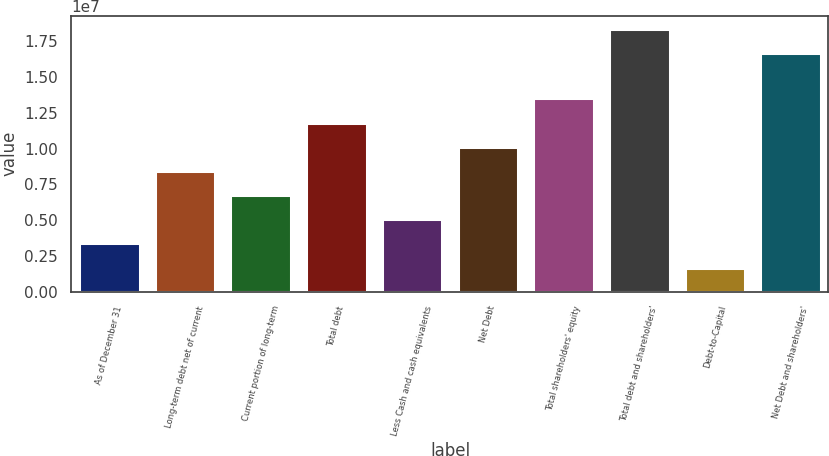Convert chart. <chart><loc_0><loc_0><loc_500><loc_500><bar_chart><fcel>As of December 31<fcel>Long-term debt net of current<fcel>Current portion of long-term<fcel>Total debt<fcel>Less Cash and cash equivalents<fcel>Net Debt<fcel>Total shareholders' equity<fcel>Total debt and shareholders'<fcel>Debt-to-Capital<fcel>Net Debt and shareholders'<nl><fcel>3.37665e+06<fcel>8.44156e+06<fcel>6.75326e+06<fcel>1.18182e+07<fcel>5.06495e+06<fcel>1.01299e+07<fcel>1.35065e+07<fcel>1.83667e+07<fcel>1.68835e+06<fcel>1.66784e+07<nl></chart> 